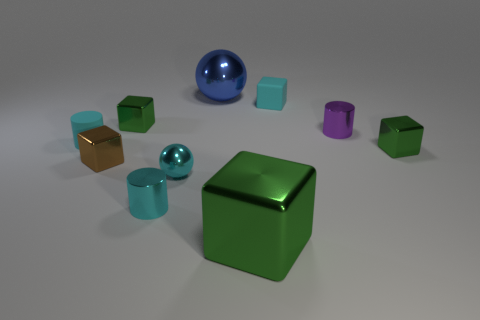What is the apparent material of the purple object? The purple object appears to be made of metal, given its lustrous finish and sharp edges.  How many total objects are there in the scene? In the scene, there are a total of nine objects: three spherical objects, five cuboid shapes, and one cylinder. 